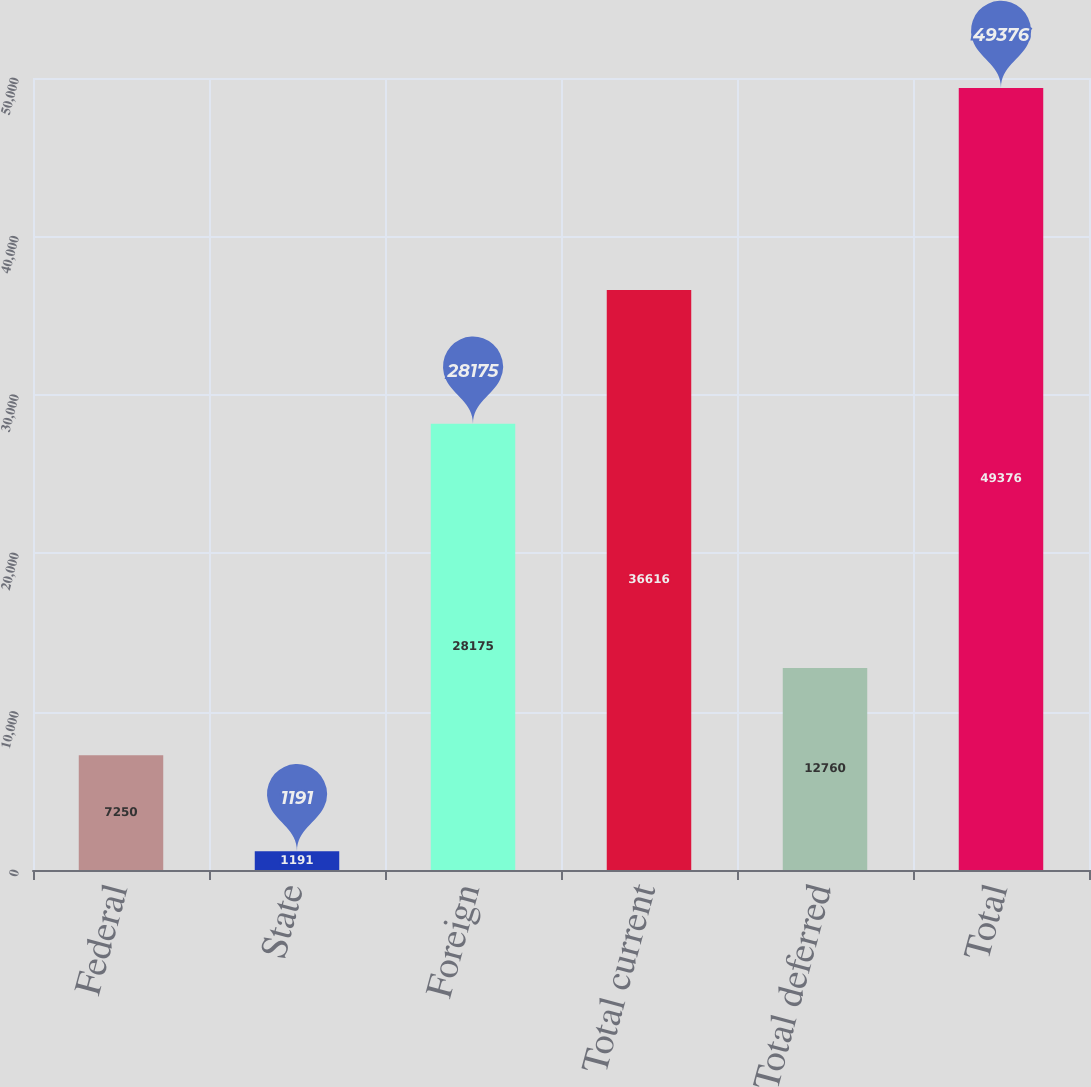Convert chart. <chart><loc_0><loc_0><loc_500><loc_500><bar_chart><fcel>Federal<fcel>State<fcel>Foreign<fcel>Total current<fcel>Total deferred<fcel>Total<nl><fcel>7250<fcel>1191<fcel>28175<fcel>36616<fcel>12760<fcel>49376<nl></chart> 